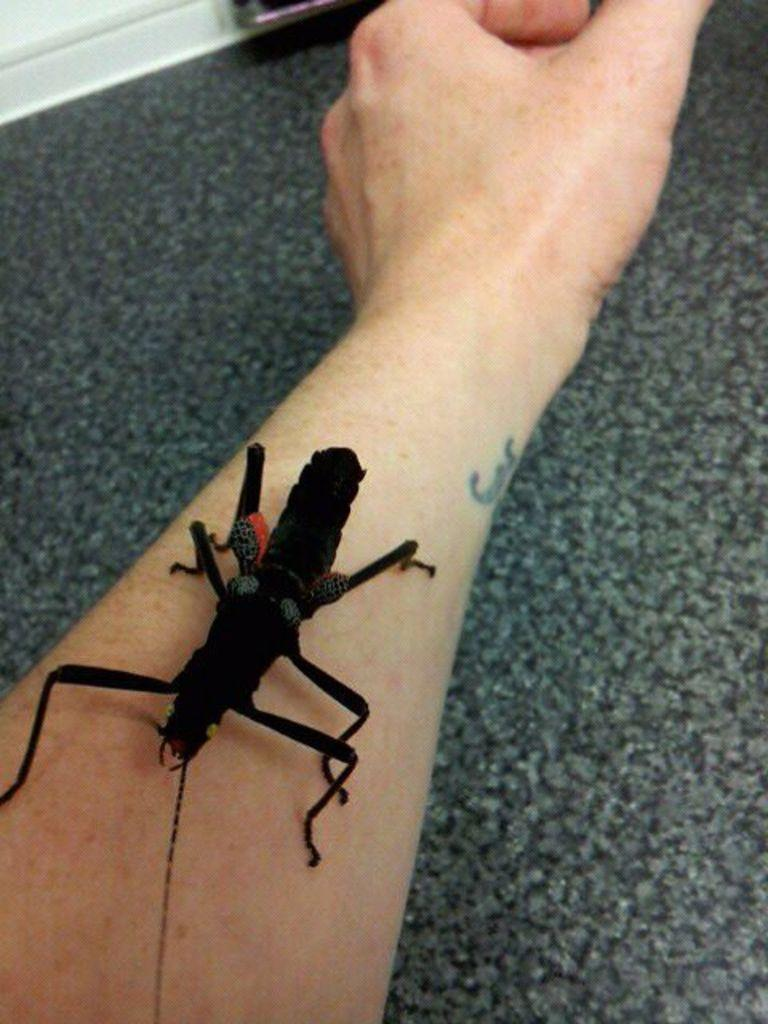What can be seen in the image related to a person? There is a person's hand in the image. What is the color of the surface where the hand is placed? The hand is on a black surface. What other object is present on the black surface? There is a black insect on the surface. How many toes can be seen on the person's foot in the image? There is no foot or toes visible in the image; only a hand is shown. 